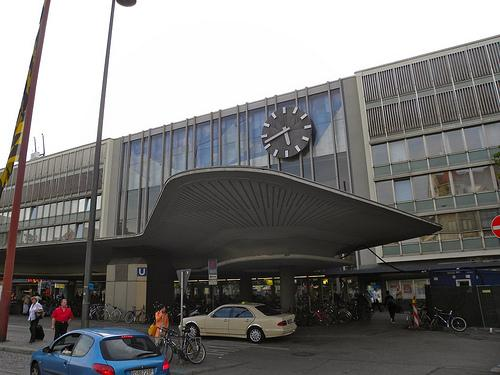Summarize the important aspects of the image in one sentence. The image features shoppers, vehicles, and bicycles near a shopping complex entrance with a clock overhead. Describe the scene unfolding in front of the shopping complex. Various cars and bikes navigate the street, while pedestrians, including a woman with a suitcase and a man in a red shirt, cross the street. List three notable color-based features of people or objects in the image. A man in a red shirt, a small blue car, and a woman wearing an orange dress. Mention the most distinctive object in the image and its location. A huge clock stands out on top of the building just outside the shopping complex entrance. Describe the presence of any relevant vehicles in the image. Multiple cars are present, including a cream-colored car, a small blue car, and a white Mercedes vehicle. Briefly discuss the overall atmosphere of the image. The image has a busy, urban vibe with people and vehicles on the road near the entrance of a shopping complex. Provide a brief overview of the primary components in the image. The image showcases a shopping complex entrance with a large clock, multiple cars, pedestrians, bikes, and various signs. 